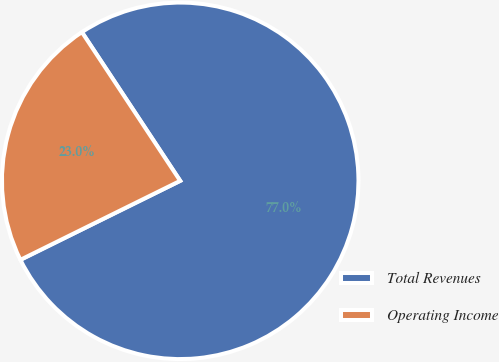<chart> <loc_0><loc_0><loc_500><loc_500><pie_chart><fcel>Total Revenues<fcel>Operating Income<nl><fcel>76.99%<fcel>23.01%<nl></chart> 